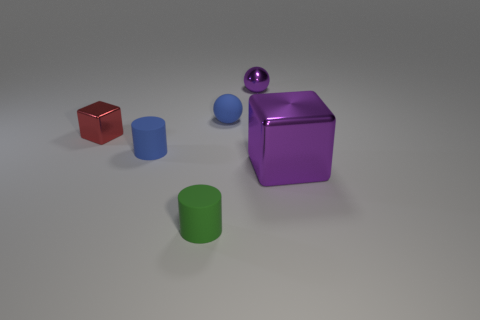There is another rubber cylinder that is the same size as the green rubber cylinder; what is its color?
Provide a short and direct response. Blue. Is there a large metal thing that has the same color as the rubber sphere?
Make the answer very short. No. What is the small blue sphere made of?
Your answer should be compact. Rubber. What number of purple things are there?
Your response must be concise. 2. There is a small rubber object that is behind the red thing; is it the same color as the matte cylinder that is to the left of the green rubber cylinder?
Your response must be concise. Yes. What is the size of the metallic sphere that is the same color as the big thing?
Offer a very short reply. Small. What number of other objects are there of the same size as the purple ball?
Provide a succinct answer. 4. There is a block to the left of the metallic sphere; what is its color?
Offer a very short reply. Red. Does the blue thing to the left of the green cylinder have the same material as the large purple thing?
Your response must be concise. No. What number of objects are both in front of the small blue ball and on the left side of the purple sphere?
Your response must be concise. 3. 